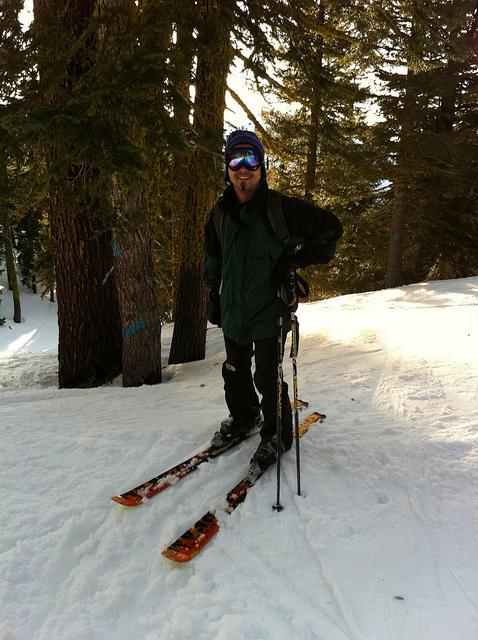What is this man wearing on his face?
Quick response, please. Goggles. What is the man holding?
Short answer required. Ski poles. What season is this?
Short answer required. Winter. 